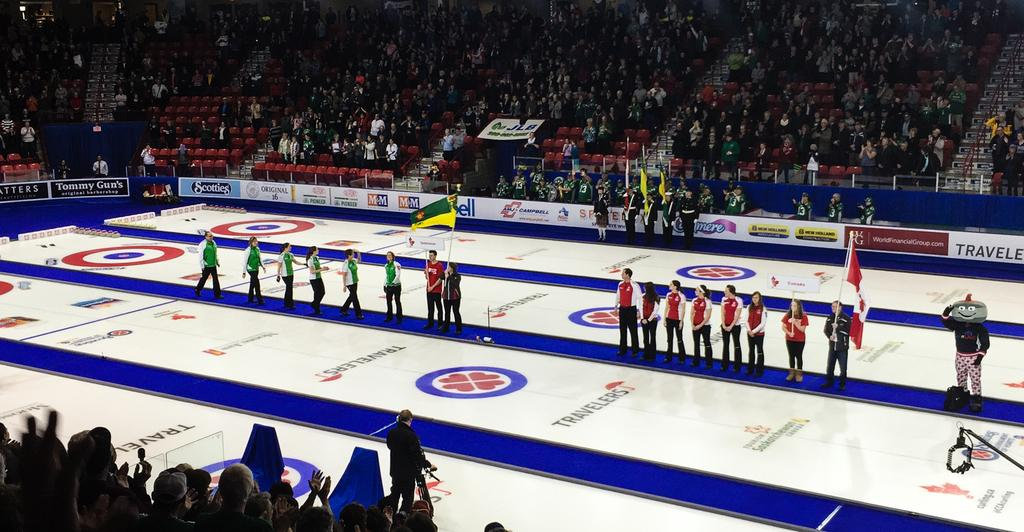<image>
Relay a brief, clear account of the picture shown. canadian womens team and another team on stadium floor with travelers insurance logos and other sponsors scotties and tommy gun's 